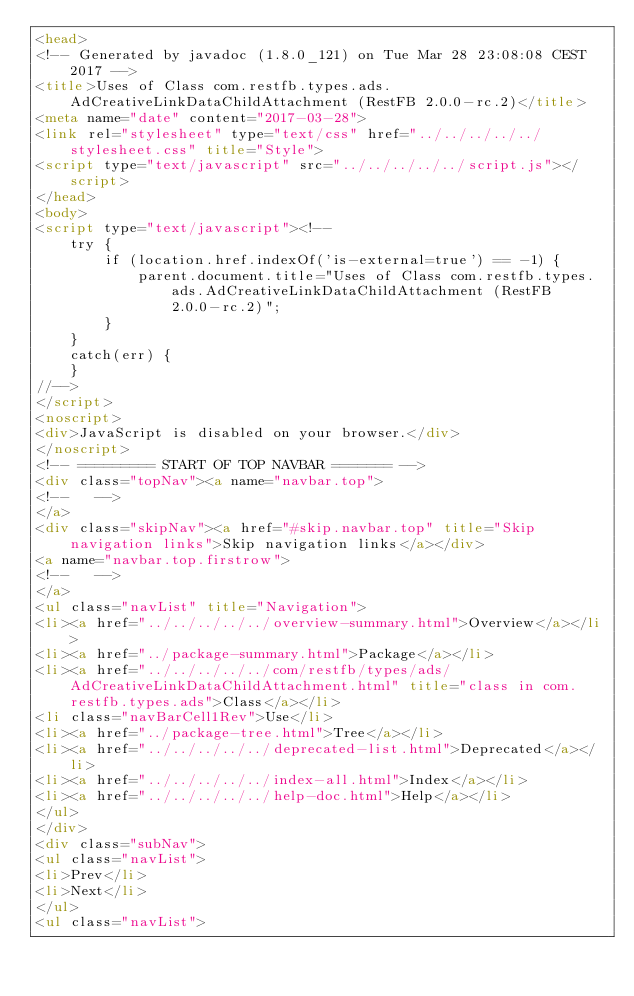<code> <loc_0><loc_0><loc_500><loc_500><_HTML_><head>
<!-- Generated by javadoc (1.8.0_121) on Tue Mar 28 23:08:08 CEST 2017 -->
<title>Uses of Class com.restfb.types.ads.AdCreativeLinkDataChildAttachment (RestFB 2.0.0-rc.2)</title>
<meta name="date" content="2017-03-28">
<link rel="stylesheet" type="text/css" href="../../../../../stylesheet.css" title="Style">
<script type="text/javascript" src="../../../../../script.js"></script>
</head>
<body>
<script type="text/javascript"><!--
    try {
        if (location.href.indexOf('is-external=true') == -1) {
            parent.document.title="Uses of Class com.restfb.types.ads.AdCreativeLinkDataChildAttachment (RestFB 2.0.0-rc.2)";
        }
    }
    catch(err) {
    }
//-->
</script>
<noscript>
<div>JavaScript is disabled on your browser.</div>
</noscript>
<!-- ========= START OF TOP NAVBAR ======= -->
<div class="topNav"><a name="navbar.top">
<!--   -->
</a>
<div class="skipNav"><a href="#skip.navbar.top" title="Skip navigation links">Skip navigation links</a></div>
<a name="navbar.top.firstrow">
<!--   -->
</a>
<ul class="navList" title="Navigation">
<li><a href="../../../../../overview-summary.html">Overview</a></li>
<li><a href="../package-summary.html">Package</a></li>
<li><a href="../../../../../com/restfb/types/ads/AdCreativeLinkDataChildAttachment.html" title="class in com.restfb.types.ads">Class</a></li>
<li class="navBarCell1Rev">Use</li>
<li><a href="../package-tree.html">Tree</a></li>
<li><a href="../../../../../deprecated-list.html">Deprecated</a></li>
<li><a href="../../../../../index-all.html">Index</a></li>
<li><a href="../../../../../help-doc.html">Help</a></li>
</ul>
</div>
<div class="subNav">
<ul class="navList">
<li>Prev</li>
<li>Next</li>
</ul>
<ul class="navList"></code> 